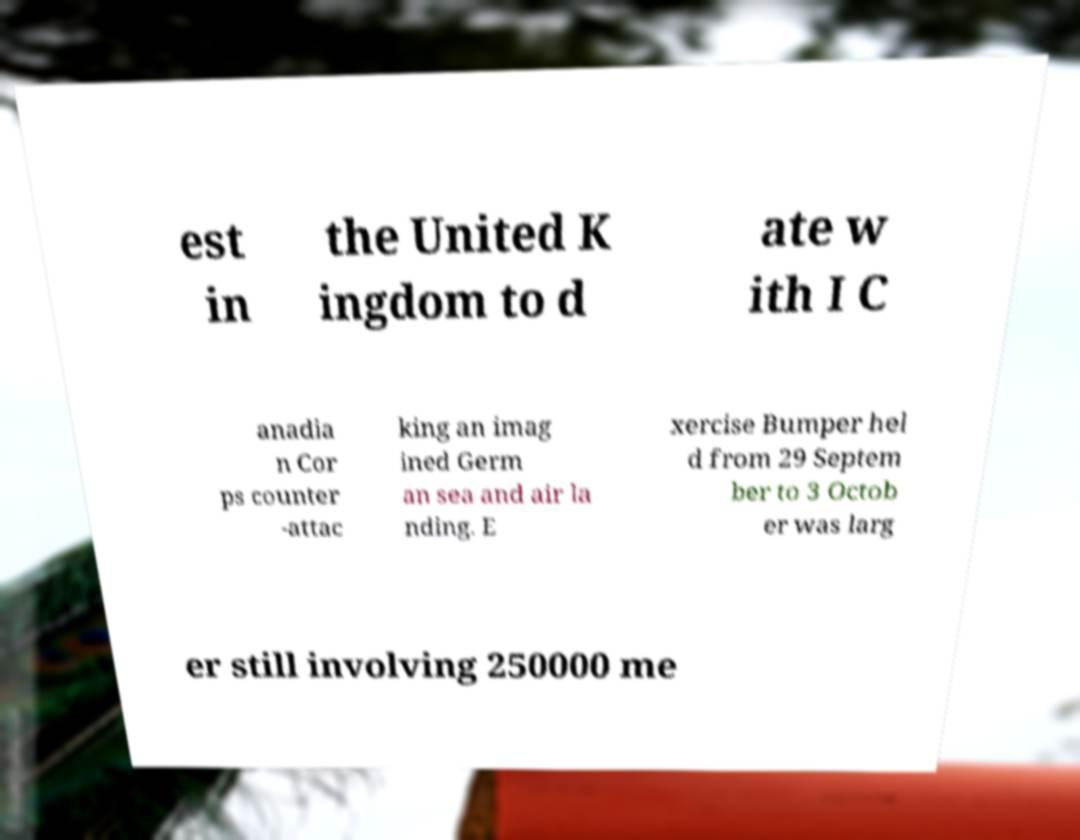Please read and relay the text visible in this image. What does it say? est in the United K ingdom to d ate w ith I C anadia n Cor ps counter -attac king an imag ined Germ an sea and air la nding. E xercise Bumper hel d from 29 Septem ber to 3 Octob er was larg er still involving 250000 me 